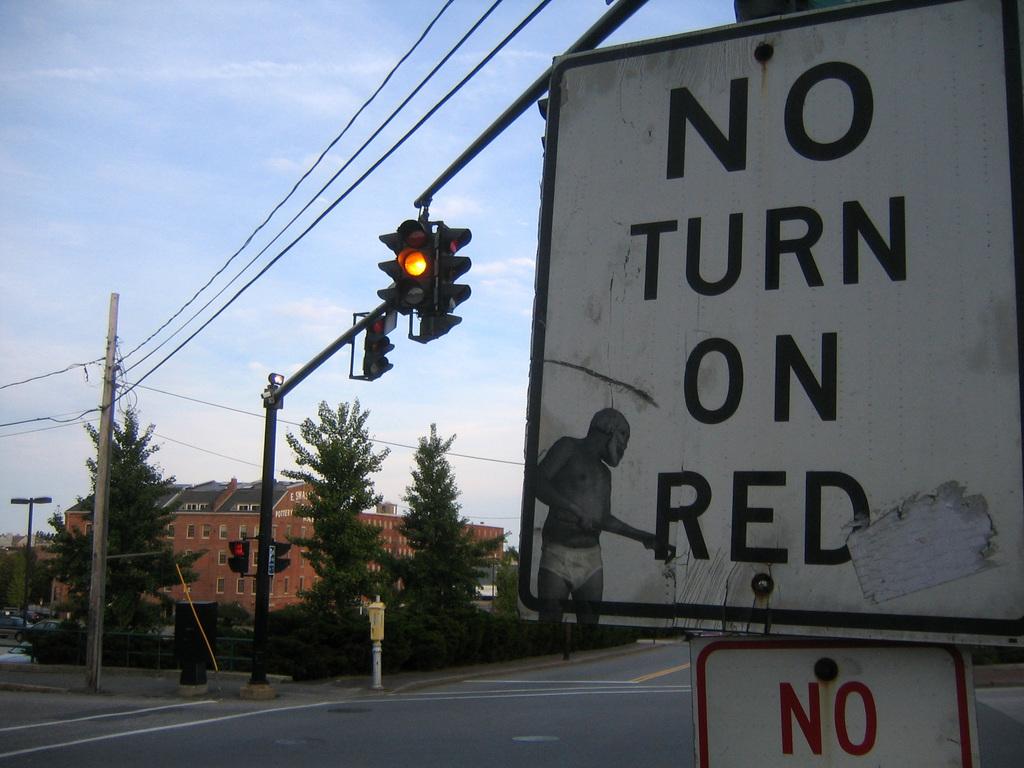What does the sign say not to do?
Offer a very short reply. Turn on red. 